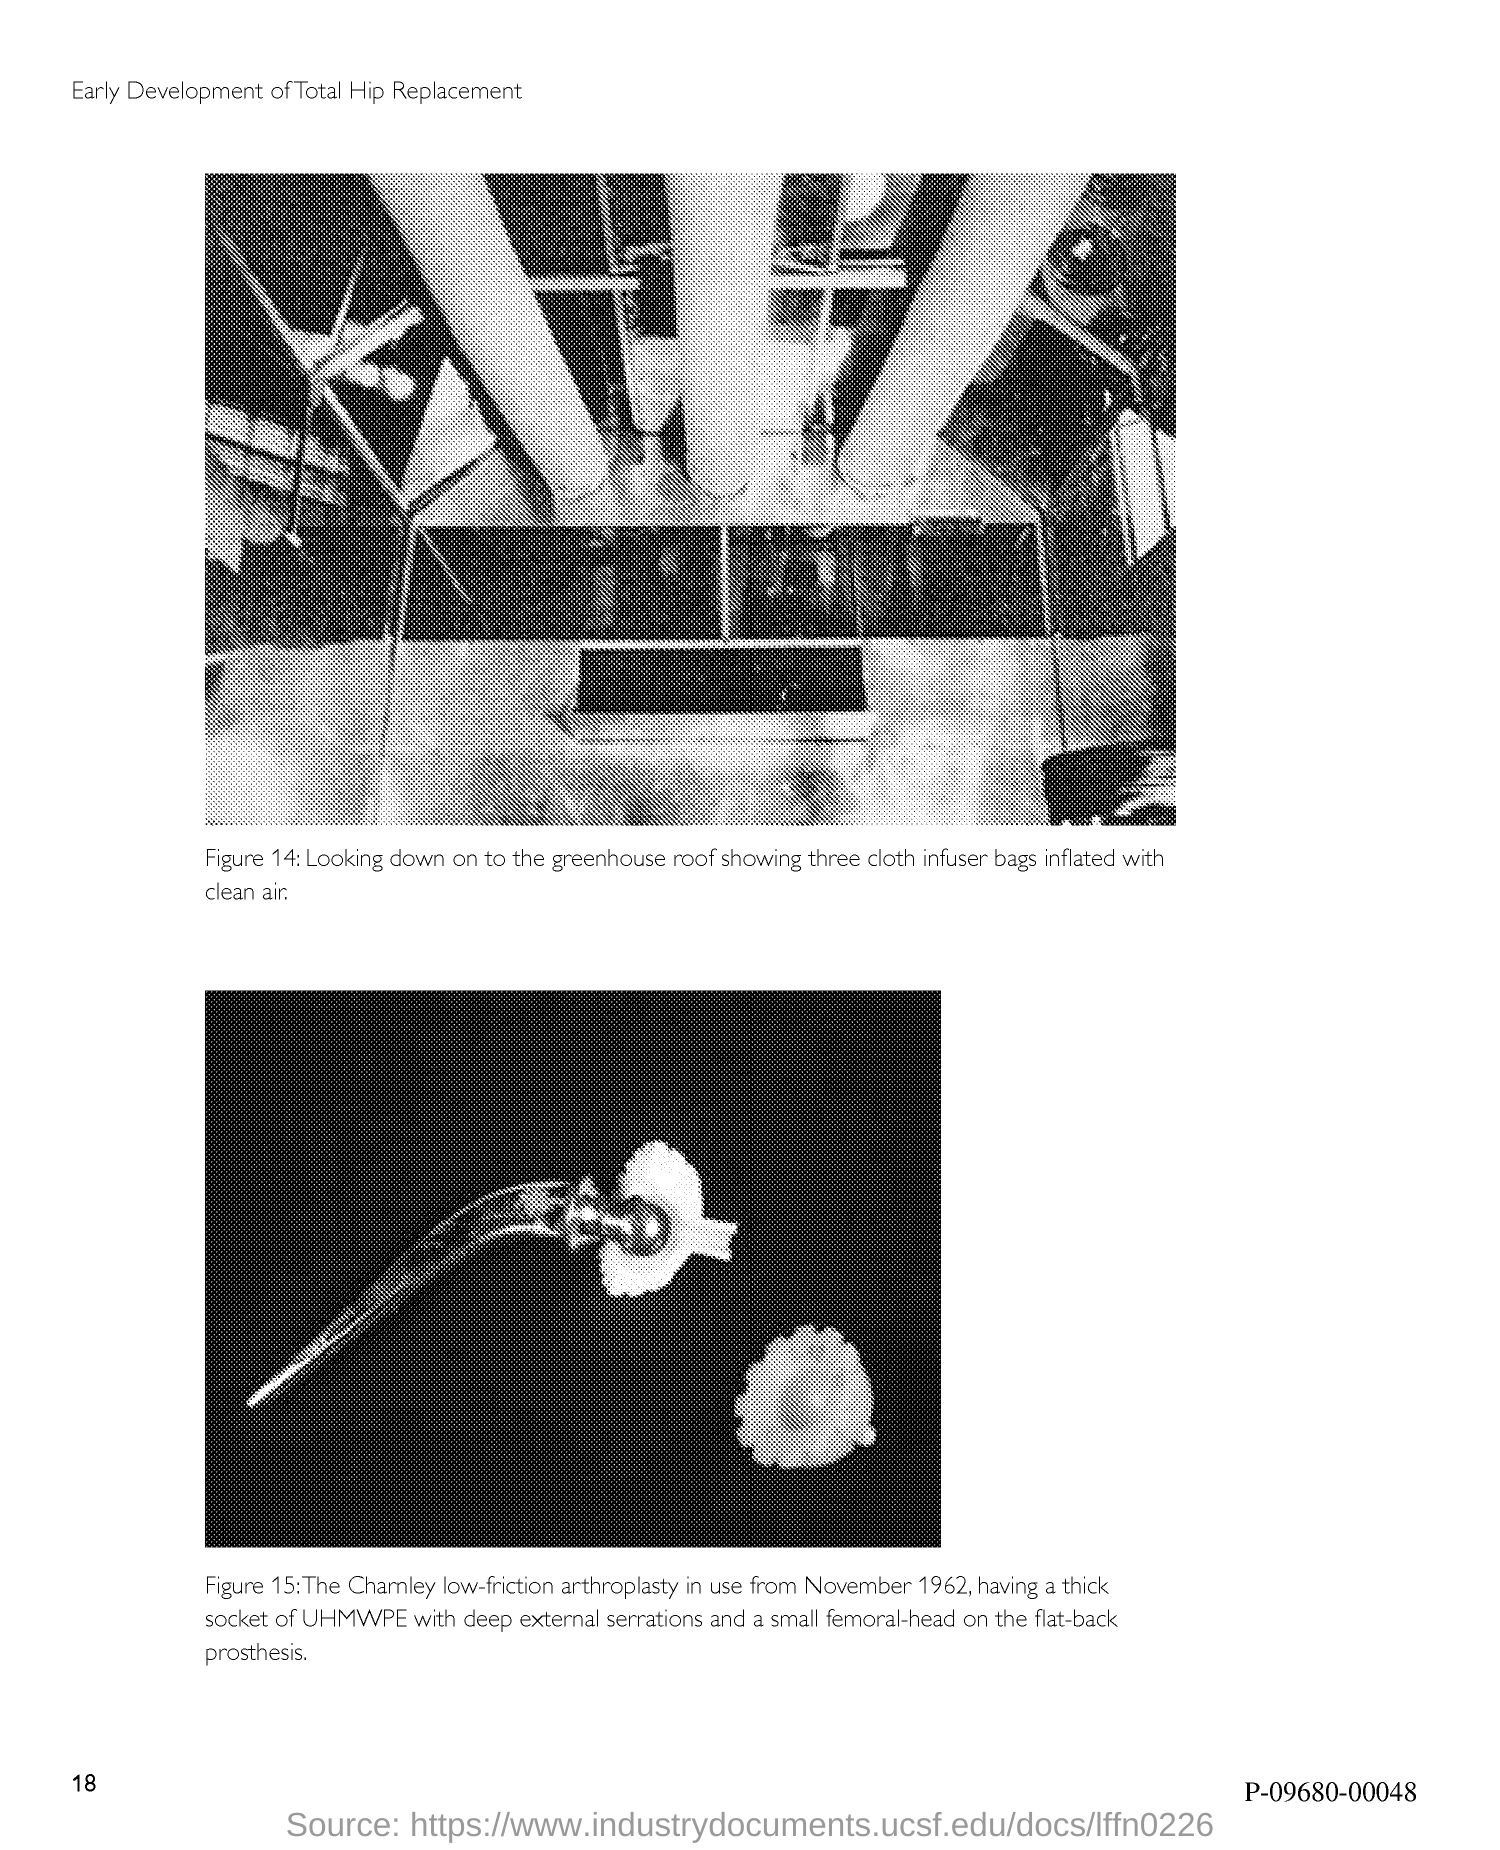What is the page no mentioned in this document?
Provide a short and direct response. 18. What does Figure 14 in this document describe?
Offer a terse response. Looking down on to the greenhouse roof showing three cloth infuser bags inflated with clean air. 